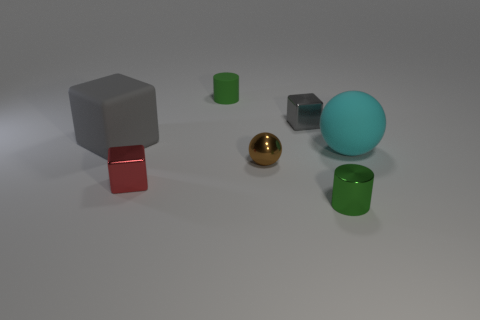What shape is the metal thing left of the small brown metal thing?
Offer a very short reply. Cube. What is the shape of the big rubber thing that is on the right side of the tiny shiny block on the right side of the small rubber cylinder?
Give a very brief answer. Sphere. Is there a big cyan object that has the same shape as the small green rubber thing?
Ensure brevity in your answer.  No. What is the shape of the gray metallic object that is the same size as the brown shiny ball?
Give a very brief answer. Cube. There is a tiny brown thing on the right side of the green thing that is behind the matte sphere; are there any small metal blocks in front of it?
Offer a very short reply. Yes. Are there any yellow cubes of the same size as the brown ball?
Give a very brief answer. No. What size is the green cylinder behind the cyan rubber sphere?
Your response must be concise. Small. There is a metal object left of the tiny cylinder behind the small green thing in front of the rubber sphere; what color is it?
Your answer should be very brief. Red. What is the color of the large rubber object that is on the right side of the green object behind the green shiny cylinder?
Your answer should be very brief. Cyan. Is the number of gray shiny things that are behind the small green shiny thing greater than the number of tiny brown spheres that are to the right of the large cyan rubber sphere?
Your answer should be compact. Yes. 